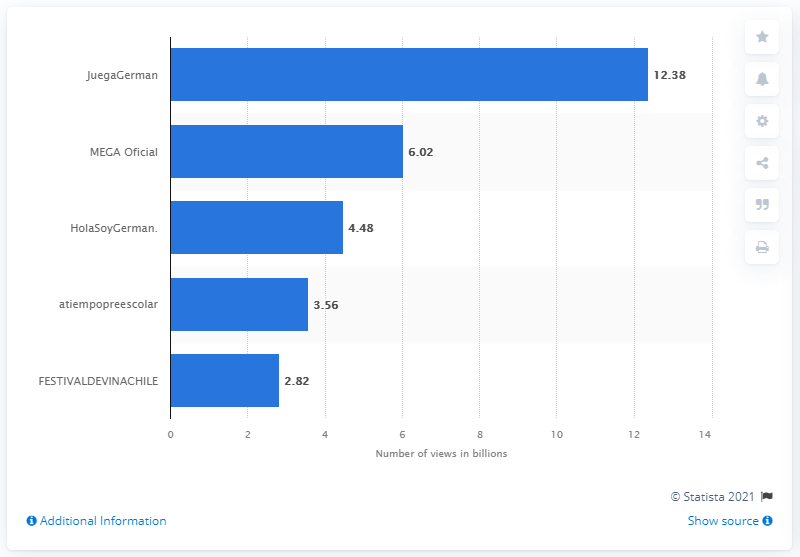Identify some key points in this picture. As of March 2021, the second most viewed YouTube channel in Chile was MEGA Oficial. As of March 2021, JuegaGerman had a total of 12,380 video views. As of March 2021, the most viewed YouTube channel in Chile was JuegaGerman. 